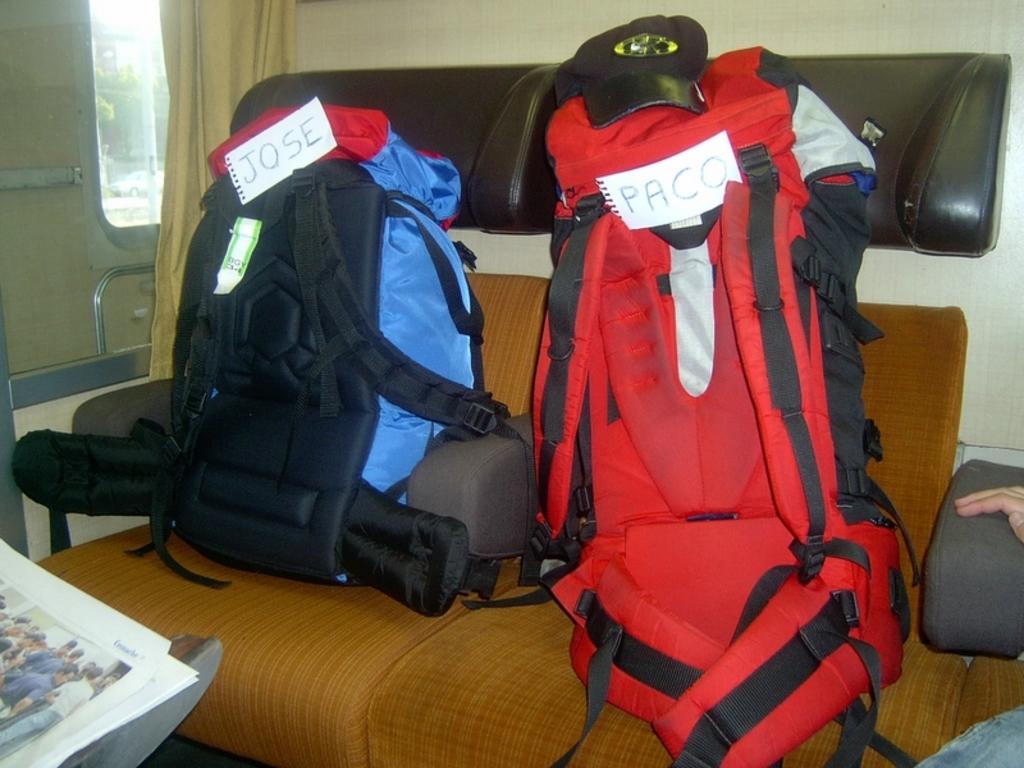Whose pack is the red one?
Give a very brief answer. Paco. Whose pack is the blue one?
Offer a terse response. Jose. 